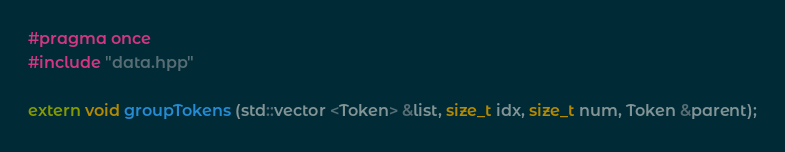Convert code to text. <code><loc_0><loc_0><loc_500><loc_500><_C++_>#pragma once
#include "data.hpp"

extern void groupTokens (std::vector <Token> &list, size_t idx, size_t num, Token &parent);
</code> 